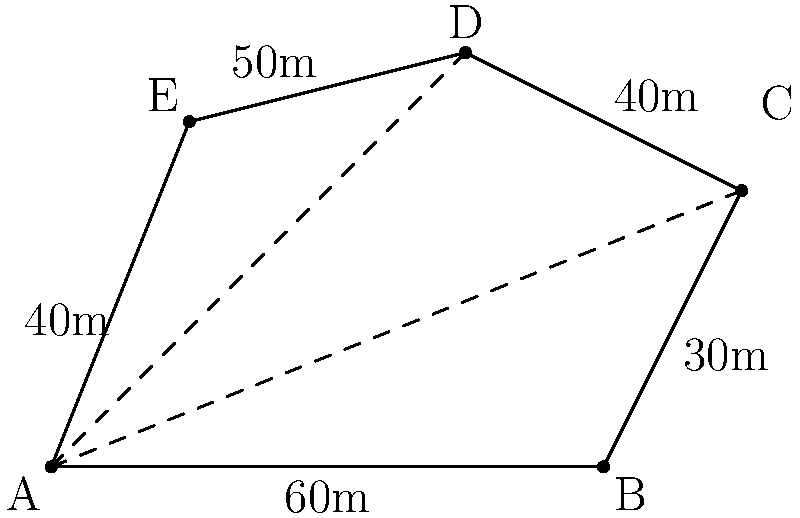The local police station's property has an irregular shape as shown in the diagram. To improve community relations, you want to calculate the area of the property for a potential community garden project. Using the triangulation method, calculate the total area of the property. All measurements are in meters. To calculate the area of the irregular-shaped property, we can use the triangulation method by dividing the shape into triangles and summing their areas.

Step 1: Divide the shape into three triangles: ABC, ACD, and ADE.

Step 2: Calculate the areas of each triangle using Heron's formula:
$A = \sqrt{s(s-a)(s-b)(s-c)}$, where $s = \frac{a+b+c}{2}$ (semi-perimeter)

Triangle ABC:
$a = 60$, $b = 30$, $c = \sqrt{60^2 + 30^2} = 67.08$
$s = \frac{60 + 30 + 67.08}{2} = 78.54$
$A_{ABC} = \sqrt{78.54(78.54-60)(78.54-30)(78.54-67.08)} = 900$ m²

Triangle ACD:
$a = 67.08$, $b = 40$, $c = \sqrt{60^2 + 60^2} = 84.85$
$s = \frac{67.08 + 40 + 84.85}{2} = 95.97$
$A_{ACD} = \sqrt{95.97(95.97-67.08)(95.97-40)(95.97-84.85)} = 1200$ m²

Triangle ADE:
$a = 50$, $b = 40$, $c = \sqrt{60^2 + 50^2} = 78.10$
$s = \frac{50 + 40 + 78.10}{2} = 84.05$
$A_{ADE} = \sqrt{84.05(84.05-50)(84.05-40)(84.05-78.10)} = 1000$ m²

Step 3: Sum the areas of all triangles:
Total Area = $A_{ABC} + A_{ACD} + A_{ADE} = 900 + 1200 + 1000 = 3100$ m²
Answer: 3100 m² 